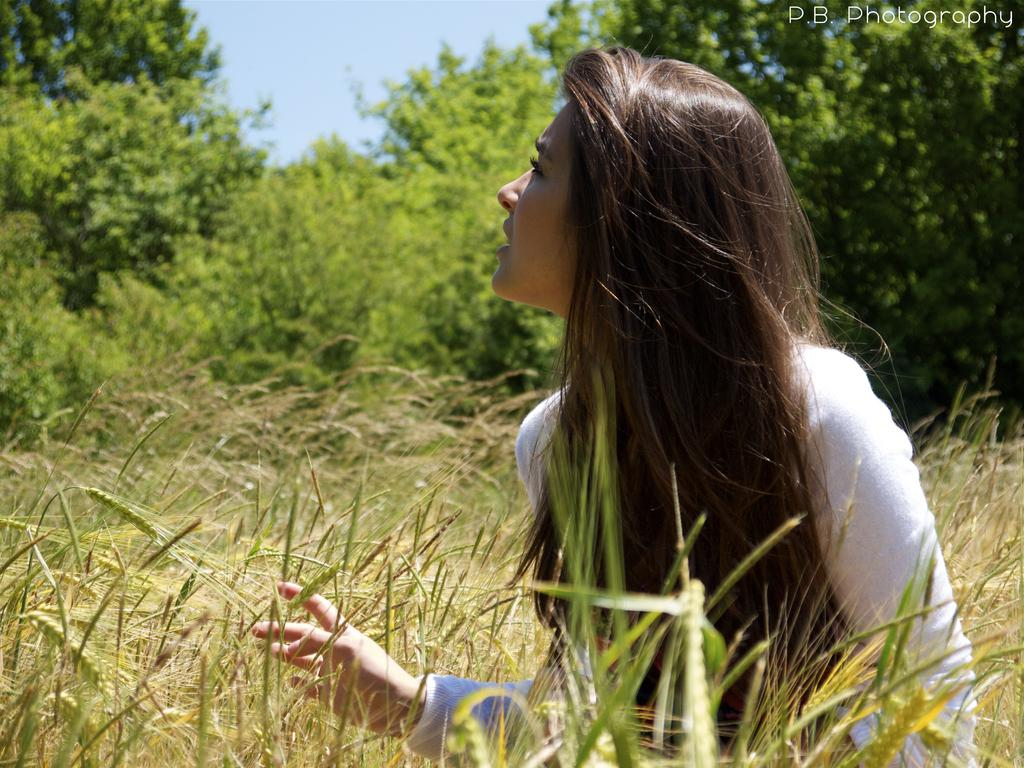Who is the main subject in the image? There is a lady in the image. What type of landscape is visible at the bottom of the image? There is a field at the bottom of the image. What can be seen in the background of the image? There are trees and the sky visible in the background of the image. What type of oil can be seen dripping from the lady's hair in the image? There is no oil or any dripping substance visible in the lady's hair in the image. 